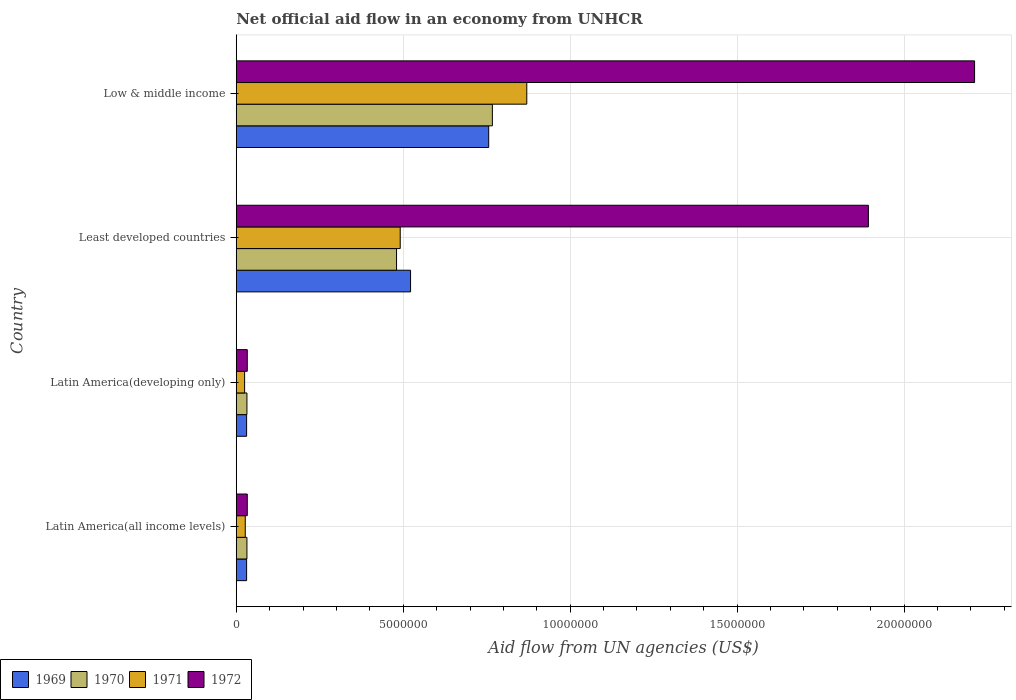Are the number of bars per tick equal to the number of legend labels?
Offer a very short reply. Yes. Are the number of bars on each tick of the Y-axis equal?
Your answer should be compact. Yes. How many bars are there on the 2nd tick from the top?
Offer a very short reply. 4. What is the label of the 3rd group of bars from the top?
Your answer should be very brief. Latin America(developing only). What is the net official aid flow in 1972 in Least developed countries?
Your answer should be compact. 1.89e+07. Across all countries, what is the maximum net official aid flow in 1972?
Give a very brief answer. 2.21e+07. Across all countries, what is the minimum net official aid flow in 1972?
Your answer should be very brief. 3.30e+05. In which country was the net official aid flow in 1971 minimum?
Keep it short and to the point. Latin America(developing only). What is the total net official aid flow in 1970 in the graph?
Ensure brevity in your answer.  1.31e+07. What is the difference between the net official aid flow in 1969 in Latin America(developing only) and that in Low & middle income?
Your answer should be very brief. -7.25e+06. What is the difference between the net official aid flow in 1970 in Least developed countries and the net official aid flow in 1971 in Low & middle income?
Provide a short and direct response. -3.90e+06. What is the average net official aid flow in 1969 per country?
Keep it short and to the point. 3.35e+06. What is the difference between the net official aid flow in 1970 and net official aid flow in 1972 in Least developed countries?
Your answer should be compact. -1.41e+07. In how many countries, is the net official aid flow in 1969 greater than 11000000 US$?
Keep it short and to the point. 0. What is the ratio of the net official aid flow in 1971 in Latin America(developing only) to that in Least developed countries?
Your answer should be very brief. 0.05. Is the net official aid flow in 1969 in Latin America(all income levels) less than that in Latin America(developing only)?
Your response must be concise. No. What is the difference between the highest and the second highest net official aid flow in 1972?
Your answer should be very brief. 3.18e+06. What is the difference between the highest and the lowest net official aid flow in 1971?
Your answer should be very brief. 8.45e+06. Is the sum of the net official aid flow in 1972 in Least developed countries and Low & middle income greater than the maximum net official aid flow in 1970 across all countries?
Offer a terse response. Yes. What does the 3rd bar from the bottom in Latin America(developing only) represents?
Offer a terse response. 1971. How many bars are there?
Keep it short and to the point. 16. Are all the bars in the graph horizontal?
Your answer should be very brief. Yes. How many countries are there in the graph?
Make the answer very short. 4. What is the difference between two consecutive major ticks on the X-axis?
Offer a terse response. 5.00e+06. Are the values on the major ticks of X-axis written in scientific E-notation?
Your answer should be compact. No. Does the graph contain any zero values?
Your answer should be very brief. No. Does the graph contain grids?
Offer a very short reply. Yes. How many legend labels are there?
Provide a short and direct response. 4. How are the legend labels stacked?
Offer a terse response. Horizontal. What is the title of the graph?
Your answer should be very brief. Net official aid flow in an economy from UNHCR. What is the label or title of the X-axis?
Offer a terse response. Aid flow from UN agencies (US$). What is the Aid flow from UN agencies (US$) of 1969 in Latin America(all income levels)?
Provide a succinct answer. 3.10e+05. What is the Aid flow from UN agencies (US$) in 1971 in Latin America(all income levels)?
Make the answer very short. 2.70e+05. What is the Aid flow from UN agencies (US$) of 1972 in Latin America(all income levels)?
Provide a succinct answer. 3.30e+05. What is the Aid flow from UN agencies (US$) in 1970 in Latin America(developing only)?
Your response must be concise. 3.20e+05. What is the Aid flow from UN agencies (US$) in 1972 in Latin America(developing only)?
Offer a very short reply. 3.30e+05. What is the Aid flow from UN agencies (US$) of 1969 in Least developed countries?
Offer a terse response. 5.22e+06. What is the Aid flow from UN agencies (US$) of 1970 in Least developed countries?
Your answer should be very brief. 4.80e+06. What is the Aid flow from UN agencies (US$) of 1971 in Least developed countries?
Make the answer very short. 4.91e+06. What is the Aid flow from UN agencies (US$) of 1972 in Least developed countries?
Your answer should be compact. 1.89e+07. What is the Aid flow from UN agencies (US$) of 1969 in Low & middle income?
Provide a succinct answer. 7.56e+06. What is the Aid flow from UN agencies (US$) in 1970 in Low & middle income?
Your answer should be compact. 7.67e+06. What is the Aid flow from UN agencies (US$) of 1971 in Low & middle income?
Provide a short and direct response. 8.70e+06. What is the Aid flow from UN agencies (US$) of 1972 in Low & middle income?
Ensure brevity in your answer.  2.21e+07. Across all countries, what is the maximum Aid flow from UN agencies (US$) in 1969?
Offer a terse response. 7.56e+06. Across all countries, what is the maximum Aid flow from UN agencies (US$) in 1970?
Your answer should be compact. 7.67e+06. Across all countries, what is the maximum Aid flow from UN agencies (US$) of 1971?
Give a very brief answer. 8.70e+06. Across all countries, what is the maximum Aid flow from UN agencies (US$) in 1972?
Make the answer very short. 2.21e+07. Across all countries, what is the minimum Aid flow from UN agencies (US$) in 1970?
Provide a short and direct response. 3.20e+05. Across all countries, what is the minimum Aid flow from UN agencies (US$) in 1972?
Your answer should be compact. 3.30e+05. What is the total Aid flow from UN agencies (US$) of 1969 in the graph?
Offer a very short reply. 1.34e+07. What is the total Aid flow from UN agencies (US$) of 1970 in the graph?
Ensure brevity in your answer.  1.31e+07. What is the total Aid flow from UN agencies (US$) in 1971 in the graph?
Make the answer very short. 1.41e+07. What is the total Aid flow from UN agencies (US$) of 1972 in the graph?
Provide a short and direct response. 4.17e+07. What is the difference between the Aid flow from UN agencies (US$) of 1969 in Latin America(all income levels) and that in Least developed countries?
Keep it short and to the point. -4.91e+06. What is the difference between the Aid flow from UN agencies (US$) in 1970 in Latin America(all income levels) and that in Least developed countries?
Provide a succinct answer. -4.48e+06. What is the difference between the Aid flow from UN agencies (US$) in 1971 in Latin America(all income levels) and that in Least developed countries?
Provide a succinct answer. -4.64e+06. What is the difference between the Aid flow from UN agencies (US$) of 1972 in Latin America(all income levels) and that in Least developed countries?
Provide a short and direct response. -1.86e+07. What is the difference between the Aid flow from UN agencies (US$) in 1969 in Latin America(all income levels) and that in Low & middle income?
Your answer should be very brief. -7.25e+06. What is the difference between the Aid flow from UN agencies (US$) of 1970 in Latin America(all income levels) and that in Low & middle income?
Make the answer very short. -7.35e+06. What is the difference between the Aid flow from UN agencies (US$) of 1971 in Latin America(all income levels) and that in Low & middle income?
Your answer should be compact. -8.43e+06. What is the difference between the Aid flow from UN agencies (US$) in 1972 in Latin America(all income levels) and that in Low & middle income?
Keep it short and to the point. -2.18e+07. What is the difference between the Aid flow from UN agencies (US$) of 1969 in Latin America(developing only) and that in Least developed countries?
Keep it short and to the point. -4.91e+06. What is the difference between the Aid flow from UN agencies (US$) of 1970 in Latin America(developing only) and that in Least developed countries?
Your answer should be compact. -4.48e+06. What is the difference between the Aid flow from UN agencies (US$) in 1971 in Latin America(developing only) and that in Least developed countries?
Offer a terse response. -4.66e+06. What is the difference between the Aid flow from UN agencies (US$) of 1972 in Latin America(developing only) and that in Least developed countries?
Provide a short and direct response. -1.86e+07. What is the difference between the Aid flow from UN agencies (US$) of 1969 in Latin America(developing only) and that in Low & middle income?
Make the answer very short. -7.25e+06. What is the difference between the Aid flow from UN agencies (US$) of 1970 in Latin America(developing only) and that in Low & middle income?
Keep it short and to the point. -7.35e+06. What is the difference between the Aid flow from UN agencies (US$) of 1971 in Latin America(developing only) and that in Low & middle income?
Ensure brevity in your answer.  -8.45e+06. What is the difference between the Aid flow from UN agencies (US$) in 1972 in Latin America(developing only) and that in Low & middle income?
Make the answer very short. -2.18e+07. What is the difference between the Aid flow from UN agencies (US$) of 1969 in Least developed countries and that in Low & middle income?
Your answer should be very brief. -2.34e+06. What is the difference between the Aid flow from UN agencies (US$) of 1970 in Least developed countries and that in Low & middle income?
Your answer should be very brief. -2.87e+06. What is the difference between the Aid flow from UN agencies (US$) of 1971 in Least developed countries and that in Low & middle income?
Make the answer very short. -3.79e+06. What is the difference between the Aid flow from UN agencies (US$) of 1972 in Least developed countries and that in Low & middle income?
Give a very brief answer. -3.18e+06. What is the difference between the Aid flow from UN agencies (US$) of 1969 in Latin America(all income levels) and the Aid flow from UN agencies (US$) of 1972 in Latin America(developing only)?
Ensure brevity in your answer.  -2.00e+04. What is the difference between the Aid flow from UN agencies (US$) in 1970 in Latin America(all income levels) and the Aid flow from UN agencies (US$) in 1971 in Latin America(developing only)?
Provide a short and direct response. 7.00e+04. What is the difference between the Aid flow from UN agencies (US$) in 1970 in Latin America(all income levels) and the Aid flow from UN agencies (US$) in 1972 in Latin America(developing only)?
Provide a short and direct response. -10000. What is the difference between the Aid flow from UN agencies (US$) of 1969 in Latin America(all income levels) and the Aid flow from UN agencies (US$) of 1970 in Least developed countries?
Offer a terse response. -4.49e+06. What is the difference between the Aid flow from UN agencies (US$) of 1969 in Latin America(all income levels) and the Aid flow from UN agencies (US$) of 1971 in Least developed countries?
Provide a succinct answer. -4.60e+06. What is the difference between the Aid flow from UN agencies (US$) in 1969 in Latin America(all income levels) and the Aid flow from UN agencies (US$) in 1972 in Least developed countries?
Keep it short and to the point. -1.86e+07. What is the difference between the Aid flow from UN agencies (US$) in 1970 in Latin America(all income levels) and the Aid flow from UN agencies (US$) in 1971 in Least developed countries?
Offer a terse response. -4.59e+06. What is the difference between the Aid flow from UN agencies (US$) of 1970 in Latin America(all income levels) and the Aid flow from UN agencies (US$) of 1972 in Least developed countries?
Provide a succinct answer. -1.86e+07. What is the difference between the Aid flow from UN agencies (US$) of 1971 in Latin America(all income levels) and the Aid flow from UN agencies (US$) of 1972 in Least developed countries?
Your answer should be compact. -1.87e+07. What is the difference between the Aid flow from UN agencies (US$) of 1969 in Latin America(all income levels) and the Aid flow from UN agencies (US$) of 1970 in Low & middle income?
Ensure brevity in your answer.  -7.36e+06. What is the difference between the Aid flow from UN agencies (US$) of 1969 in Latin America(all income levels) and the Aid flow from UN agencies (US$) of 1971 in Low & middle income?
Ensure brevity in your answer.  -8.39e+06. What is the difference between the Aid flow from UN agencies (US$) in 1969 in Latin America(all income levels) and the Aid flow from UN agencies (US$) in 1972 in Low & middle income?
Your response must be concise. -2.18e+07. What is the difference between the Aid flow from UN agencies (US$) of 1970 in Latin America(all income levels) and the Aid flow from UN agencies (US$) of 1971 in Low & middle income?
Keep it short and to the point. -8.38e+06. What is the difference between the Aid flow from UN agencies (US$) in 1970 in Latin America(all income levels) and the Aid flow from UN agencies (US$) in 1972 in Low & middle income?
Offer a very short reply. -2.18e+07. What is the difference between the Aid flow from UN agencies (US$) of 1971 in Latin America(all income levels) and the Aid flow from UN agencies (US$) of 1972 in Low & middle income?
Ensure brevity in your answer.  -2.18e+07. What is the difference between the Aid flow from UN agencies (US$) in 1969 in Latin America(developing only) and the Aid flow from UN agencies (US$) in 1970 in Least developed countries?
Provide a succinct answer. -4.49e+06. What is the difference between the Aid flow from UN agencies (US$) in 1969 in Latin America(developing only) and the Aid flow from UN agencies (US$) in 1971 in Least developed countries?
Offer a terse response. -4.60e+06. What is the difference between the Aid flow from UN agencies (US$) of 1969 in Latin America(developing only) and the Aid flow from UN agencies (US$) of 1972 in Least developed countries?
Make the answer very short. -1.86e+07. What is the difference between the Aid flow from UN agencies (US$) in 1970 in Latin America(developing only) and the Aid flow from UN agencies (US$) in 1971 in Least developed countries?
Give a very brief answer. -4.59e+06. What is the difference between the Aid flow from UN agencies (US$) in 1970 in Latin America(developing only) and the Aid flow from UN agencies (US$) in 1972 in Least developed countries?
Give a very brief answer. -1.86e+07. What is the difference between the Aid flow from UN agencies (US$) in 1971 in Latin America(developing only) and the Aid flow from UN agencies (US$) in 1972 in Least developed countries?
Keep it short and to the point. -1.87e+07. What is the difference between the Aid flow from UN agencies (US$) of 1969 in Latin America(developing only) and the Aid flow from UN agencies (US$) of 1970 in Low & middle income?
Provide a succinct answer. -7.36e+06. What is the difference between the Aid flow from UN agencies (US$) of 1969 in Latin America(developing only) and the Aid flow from UN agencies (US$) of 1971 in Low & middle income?
Provide a short and direct response. -8.39e+06. What is the difference between the Aid flow from UN agencies (US$) of 1969 in Latin America(developing only) and the Aid flow from UN agencies (US$) of 1972 in Low & middle income?
Ensure brevity in your answer.  -2.18e+07. What is the difference between the Aid flow from UN agencies (US$) of 1970 in Latin America(developing only) and the Aid flow from UN agencies (US$) of 1971 in Low & middle income?
Provide a succinct answer. -8.38e+06. What is the difference between the Aid flow from UN agencies (US$) in 1970 in Latin America(developing only) and the Aid flow from UN agencies (US$) in 1972 in Low & middle income?
Offer a very short reply. -2.18e+07. What is the difference between the Aid flow from UN agencies (US$) in 1971 in Latin America(developing only) and the Aid flow from UN agencies (US$) in 1972 in Low & middle income?
Your answer should be compact. -2.19e+07. What is the difference between the Aid flow from UN agencies (US$) of 1969 in Least developed countries and the Aid flow from UN agencies (US$) of 1970 in Low & middle income?
Offer a very short reply. -2.45e+06. What is the difference between the Aid flow from UN agencies (US$) of 1969 in Least developed countries and the Aid flow from UN agencies (US$) of 1971 in Low & middle income?
Ensure brevity in your answer.  -3.48e+06. What is the difference between the Aid flow from UN agencies (US$) in 1969 in Least developed countries and the Aid flow from UN agencies (US$) in 1972 in Low & middle income?
Offer a very short reply. -1.69e+07. What is the difference between the Aid flow from UN agencies (US$) in 1970 in Least developed countries and the Aid flow from UN agencies (US$) in 1971 in Low & middle income?
Your answer should be very brief. -3.90e+06. What is the difference between the Aid flow from UN agencies (US$) of 1970 in Least developed countries and the Aid flow from UN agencies (US$) of 1972 in Low & middle income?
Your response must be concise. -1.73e+07. What is the difference between the Aid flow from UN agencies (US$) in 1971 in Least developed countries and the Aid flow from UN agencies (US$) in 1972 in Low & middle income?
Make the answer very short. -1.72e+07. What is the average Aid flow from UN agencies (US$) in 1969 per country?
Your response must be concise. 3.35e+06. What is the average Aid flow from UN agencies (US$) in 1970 per country?
Keep it short and to the point. 3.28e+06. What is the average Aid flow from UN agencies (US$) in 1971 per country?
Provide a short and direct response. 3.53e+06. What is the average Aid flow from UN agencies (US$) in 1972 per country?
Keep it short and to the point. 1.04e+07. What is the difference between the Aid flow from UN agencies (US$) of 1971 and Aid flow from UN agencies (US$) of 1972 in Latin America(all income levels)?
Your answer should be compact. -6.00e+04. What is the difference between the Aid flow from UN agencies (US$) of 1969 and Aid flow from UN agencies (US$) of 1970 in Latin America(developing only)?
Your answer should be very brief. -10000. What is the difference between the Aid flow from UN agencies (US$) of 1970 and Aid flow from UN agencies (US$) of 1972 in Latin America(developing only)?
Give a very brief answer. -10000. What is the difference between the Aid flow from UN agencies (US$) of 1969 and Aid flow from UN agencies (US$) of 1970 in Least developed countries?
Keep it short and to the point. 4.20e+05. What is the difference between the Aid flow from UN agencies (US$) in 1969 and Aid flow from UN agencies (US$) in 1972 in Least developed countries?
Your answer should be compact. -1.37e+07. What is the difference between the Aid flow from UN agencies (US$) in 1970 and Aid flow from UN agencies (US$) in 1972 in Least developed countries?
Offer a very short reply. -1.41e+07. What is the difference between the Aid flow from UN agencies (US$) of 1971 and Aid flow from UN agencies (US$) of 1972 in Least developed countries?
Your answer should be compact. -1.40e+07. What is the difference between the Aid flow from UN agencies (US$) of 1969 and Aid flow from UN agencies (US$) of 1970 in Low & middle income?
Your answer should be very brief. -1.10e+05. What is the difference between the Aid flow from UN agencies (US$) in 1969 and Aid flow from UN agencies (US$) in 1971 in Low & middle income?
Keep it short and to the point. -1.14e+06. What is the difference between the Aid flow from UN agencies (US$) of 1969 and Aid flow from UN agencies (US$) of 1972 in Low & middle income?
Provide a succinct answer. -1.46e+07. What is the difference between the Aid flow from UN agencies (US$) of 1970 and Aid flow from UN agencies (US$) of 1971 in Low & middle income?
Ensure brevity in your answer.  -1.03e+06. What is the difference between the Aid flow from UN agencies (US$) in 1970 and Aid flow from UN agencies (US$) in 1972 in Low & middle income?
Your answer should be very brief. -1.44e+07. What is the difference between the Aid flow from UN agencies (US$) in 1971 and Aid flow from UN agencies (US$) in 1972 in Low & middle income?
Provide a succinct answer. -1.34e+07. What is the ratio of the Aid flow from UN agencies (US$) of 1969 in Latin America(all income levels) to that in Latin America(developing only)?
Offer a very short reply. 1. What is the ratio of the Aid flow from UN agencies (US$) of 1970 in Latin America(all income levels) to that in Latin America(developing only)?
Offer a very short reply. 1. What is the ratio of the Aid flow from UN agencies (US$) in 1969 in Latin America(all income levels) to that in Least developed countries?
Your answer should be compact. 0.06. What is the ratio of the Aid flow from UN agencies (US$) in 1970 in Latin America(all income levels) to that in Least developed countries?
Provide a short and direct response. 0.07. What is the ratio of the Aid flow from UN agencies (US$) of 1971 in Latin America(all income levels) to that in Least developed countries?
Provide a short and direct response. 0.06. What is the ratio of the Aid flow from UN agencies (US$) of 1972 in Latin America(all income levels) to that in Least developed countries?
Your answer should be compact. 0.02. What is the ratio of the Aid flow from UN agencies (US$) in 1969 in Latin America(all income levels) to that in Low & middle income?
Ensure brevity in your answer.  0.04. What is the ratio of the Aid flow from UN agencies (US$) in 1970 in Latin America(all income levels) to that in Low & middle income?
Make the answer very short. 0.04. What is the ratio of the Aid flow from UN agencies (US$) in 1971 in Latin America(all income levels) to that in Low & middle income?
Your response must be concise. 0.03. What is the ratio of the Aid flow from UN agencies (US$) in 1972 in Latin America(all income levels) to that in Low & middle income?
Offer a terse response. 0.01. What is the ratio of the Aid flow from UN agencies (US$) in 1969 in Latin America(developing only) to that in Least developed countries?
Provide a succinct answer. 0.06. What is the ratio of the Aid flow from UN agencies (US$) in 1970 in Latin America(developing only) to that in Least developed countries?
Offer a very short reply. 0.07. What is the ratio of the Aid flow from UN agencies (US$) of 1971 in Latin America(developing only) to that in Least developed countries?
Your response must be concise. 0.05. What is the ratio of the Aid flow from UN agencies (US$) of 1972 in Latin America(developing only) to that in Least developed countries?
Your response must be concise. 0.02. What is the ratio of the Aid flow from UN agencies (US$) of 1969 in Latin America(developing only) to that in Low & middle income?
Offer a terse response. 0.04. What is the ratio of the Aid flow from UN agencies (US$) of 1970 in Latin America(developing only) to that in Low & middle income?
Your answer should be very brief. 0.04. What is the ratio of the Aid flow from UN agencies (US$) in 1971 in Latin America(developing only) to that in Low & middle income?
Your answer should be compact. 0.03. What is the ratio of the Aid flow from UN agencies (US$) in 1972 in Latin America(developing only) to that in Low & middle income?
Your answer should be compact. 0.01. What is the ratio of the Aid flow from UN agencies (US$) of 1969 in Least developed countries to that in Low & middle income?
Give a very brief answer. 0.69. What is the ratio of the Aid flow from UN agencies (US$) of 1970 in Least developed countries to that in Low & middle income?
Make the answer very short. 0.63. What is the ratio of the Aid flow from UN agencies (US$) of 1971 in Least developed countries to that in Low & middle income?
Make the answer very short. 0.56. What is the ratio of the Aid flow from UN agencies (US$) of 1972 in Least developed countries to that in Low & middle income?
Your response must be concise. 0.86. What is the difference between the highest and the second highest Aid flow from UN agencies (US$) in 1969?
Make the answer very short. 2.34e+06. What is the difference between the highest and the second highest Aid flow from UN agencies (US$) in 1970?
Give a very brief answer. 2.87e+06. What is the difference between the highest and the second highest Aid flow from UN agencies (US$) of 1971?
Keep it short and to the point. 3.79e+06. What is the difference between the highest and the second highest Aid flow from UN agencies (US$) of 1972?
Ensure brevity in your answer.  3.18e+06. What is the difference between the highest and the lowest Aid flow from UN agencies (US$) in 1969?
Provide a succinct answer. 7.25e+06. What is the difference between the highest and the lowest Aid flow from UN agencies (US$) of 1970?
Give a very brief answer. 7.35e+06. What is the difference between the highest and the lowest Aid flow from UN agencies (US$) in 1971?
Your answer should be very brief. 8.45e+06. What is the difference between the highest and the lowest Aid flow from UN agencies (US$) in 1972?
Offer a very short reply. 2.18e+07. 